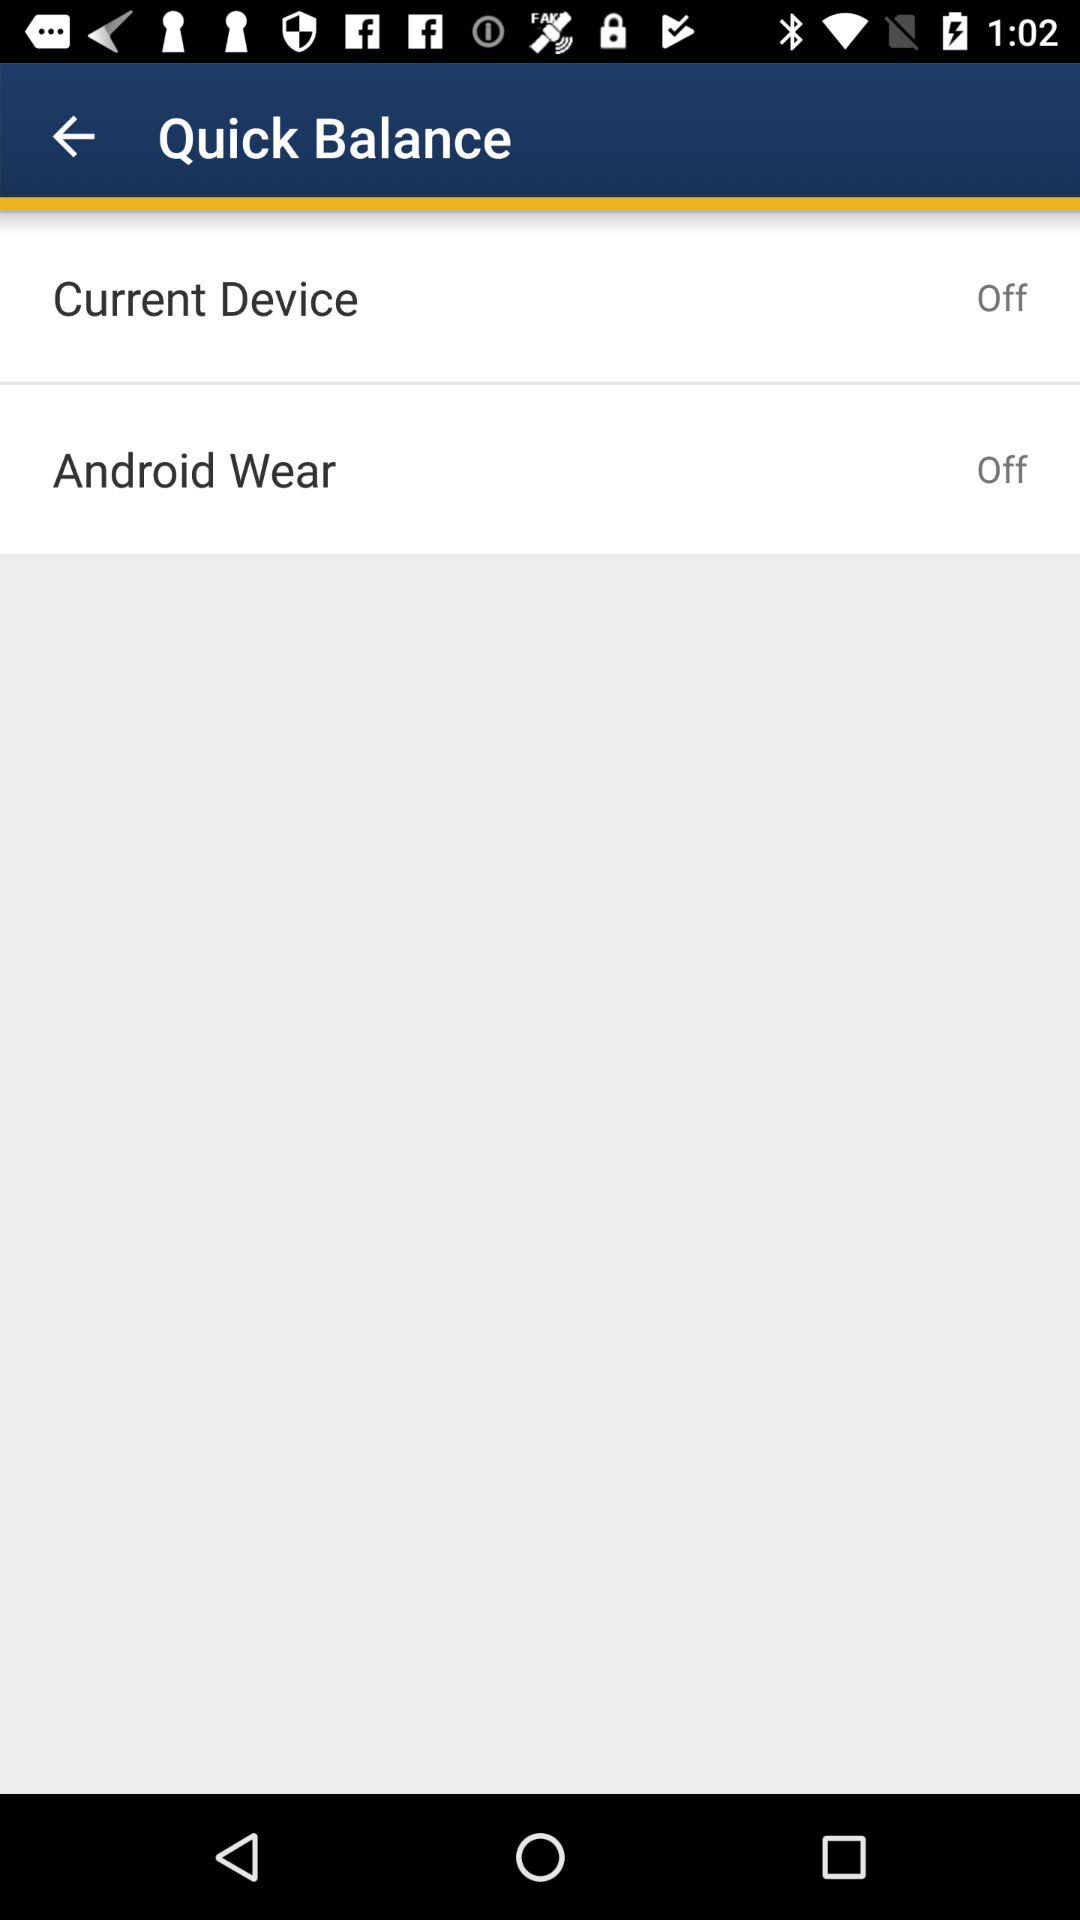What's the status of "Current Device"? The status of "Current Device" is "off". 